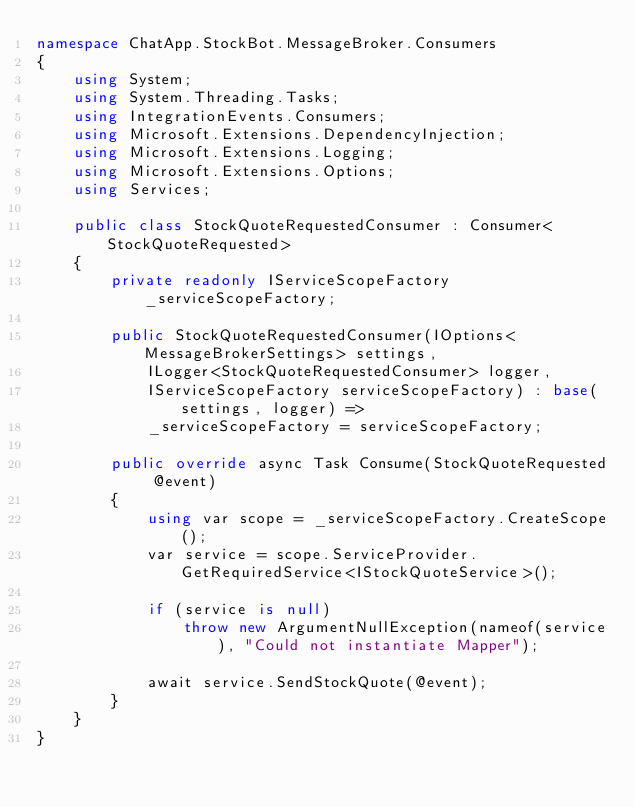Convert code to text. <code><loc_0><loc_0><loc_500><loc_500><_C#_>namespace ChatApp.StockBot.MessageBroker.Consumers
{
    using System;
    using System.Threading.Tasks;
    using IntegrationEvents.Consumers;
    using Microsoft.Extensions.DependencyInjection;
    using Microsoft.Extensions.Logging;
    using Microsoft.Extensions.Options;
    using Services;

    public class StockQuoteRequestedConsumer : Consumer<StockQuoteRequested>
    {
        private readonly IServiceScopeFactory _serviceScopeFactory;

        public StockQuoteRequestedConsumer(IOptions<MessageBrokerSettings> settings,
            ILogger<StockQuoteRequestedConsumer> logger,
            IServiceScopeFactory serviceScopeFactory) : base(settings, logger) =>
            _serviceScopeFactory = serviceScopeFactory;

        public override async Task Consume(StockQuoteRequested @event)
        {
            using var scope = _serviceScopeFactory.CreateScope();
            var service = scope.ServiceProvider.GetRequiredService<IStockQuoteService>();

            if (service is null)
                throw new ArgumentNullException(nameof(service), "Could not instantiate Mapper");

            await service.SendStockQuote(@event);
        }
    }
}</code> 